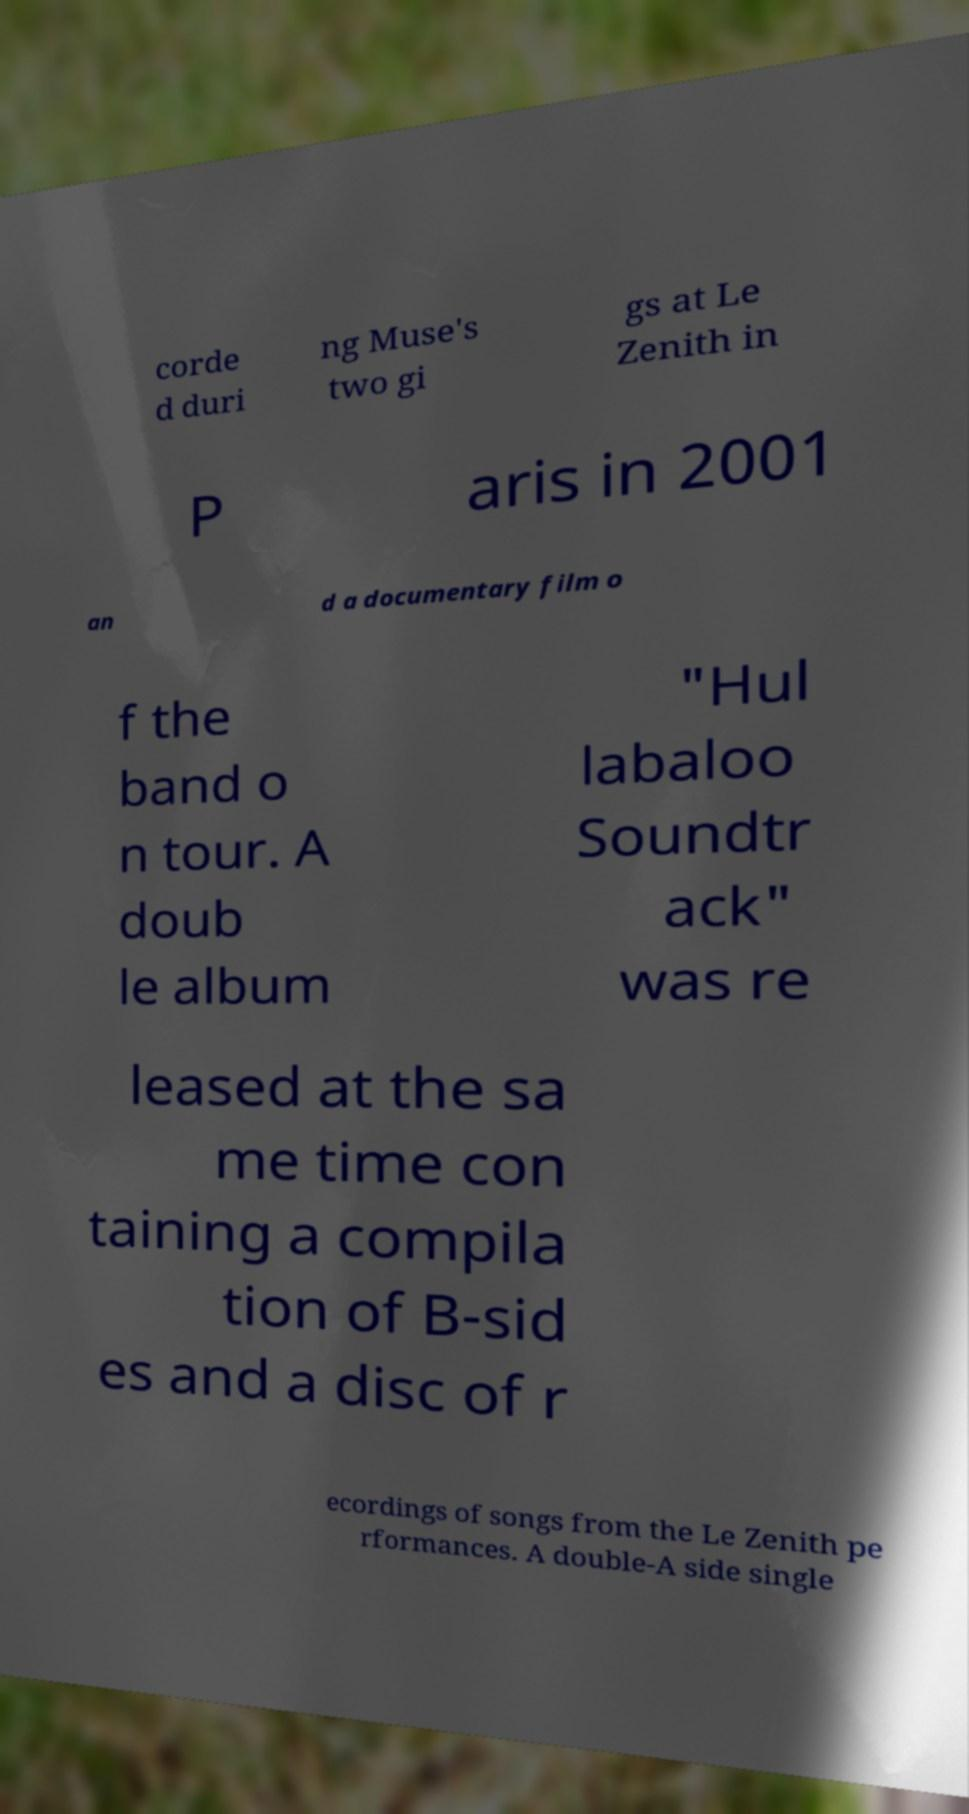Could you extract and type out the text from this image? corde d duri ng Muse's two gi gs at Le Zenith in P aris in 2001 an d a documentary film o f the band o n tour. A doub le album "Hul labaloo Soundtr ack" was re leased at the sa me time con taining a compila tion of B-sid es and a disc of r ecordings of songs from the Le Zenith pe rformances. A double-A side single 